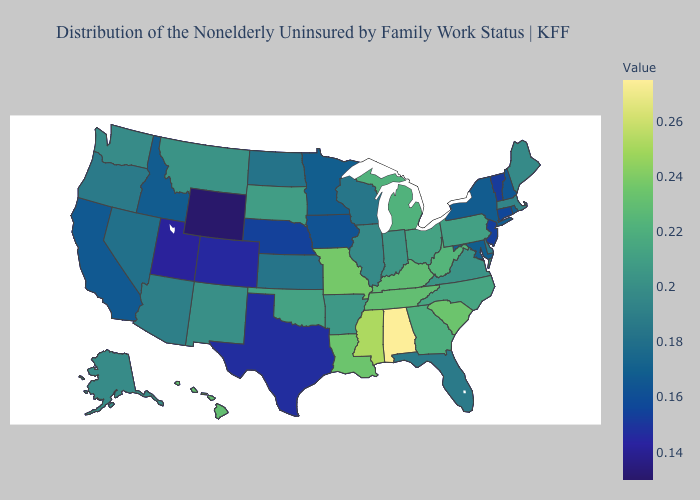Does Washington have the highest value in the USA?
Answer briefly. No. Among the states that border Kentucky , does Missouri have the highest value?
Be succinct. Yes. 